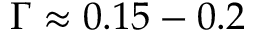<formula> <loc_0><loc_0><loc_500><loc_500>\Gamma \approx 0 . 1 5 - 0 . 2</formula> 